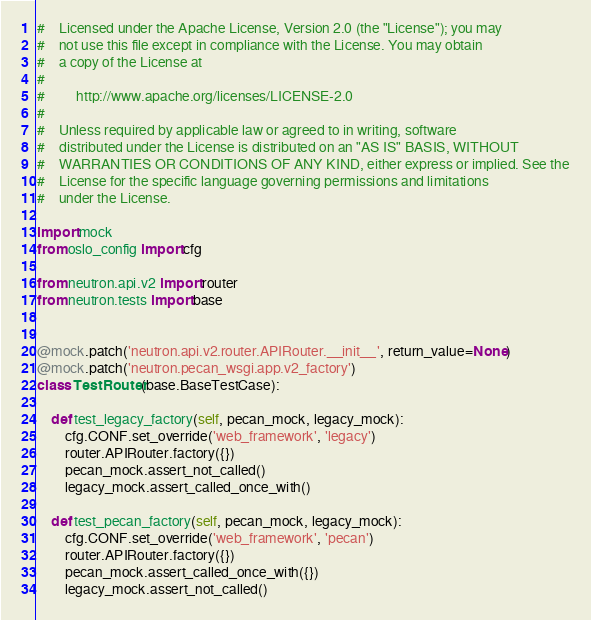<code> <loc_0><loc_0><loc_500><loc_500><_Python_>#    Licensed under the Apache License, Version 2.0 (the "License"); you may
#    not use this file except in compliance with the License. You may obtain
#    a copy of the License at
#
#         http://www.apache.org/licenses/LICENSE-2.0
#
#    Unless required by applicable law or agreed to in writing, software
#    distributed under the License is distributed on an "AS IS" BASIS, WITHOUT
#    WARRANTIES OR CONDITIONS OF ANY KIND, either express or implied. See the
#    License for the specific language governing permissions and limitations
#    under the License.

import mock
from oslo_config import cfg

from neutron.api.v2 import router
from neutron.tests import base


@mock.patch('neutron.api.v2.router.APIRouter.__init__', return_value=None)
@mock.patch('neutron.pecan_wsgi.app.v2_factory')
class TestRouter(base.BaseTestCase):

    def test_legacy_factory(self, pecan_mock, legacy_mock):
        cfg.CONF.set_override('web_framework', 'legacy')
        router.APIRouter.factory({})
        pecan_mock.assert_not_called()
        legacy_mock.assert_called_once_with()

    def test_pecan_factory(self, pecan_mock, legacy_mock):
        cfg.CONF.set_override('web_framework', 'pecan')
        router.APIRouter.factory({})
        pecan_mock.assert_called_once_with({})
        legacy_mock.assert_not_called()
</code> 